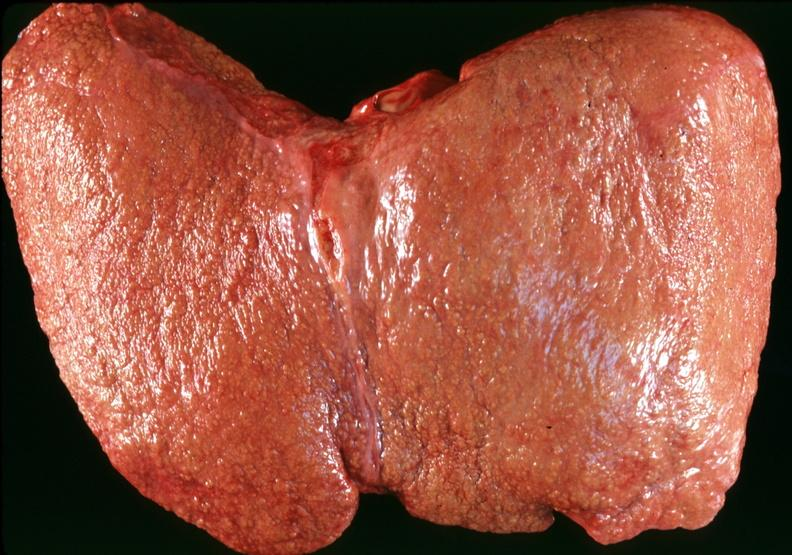s hepatobiliary present?
Answer the question using a single word or phrase. Yes 